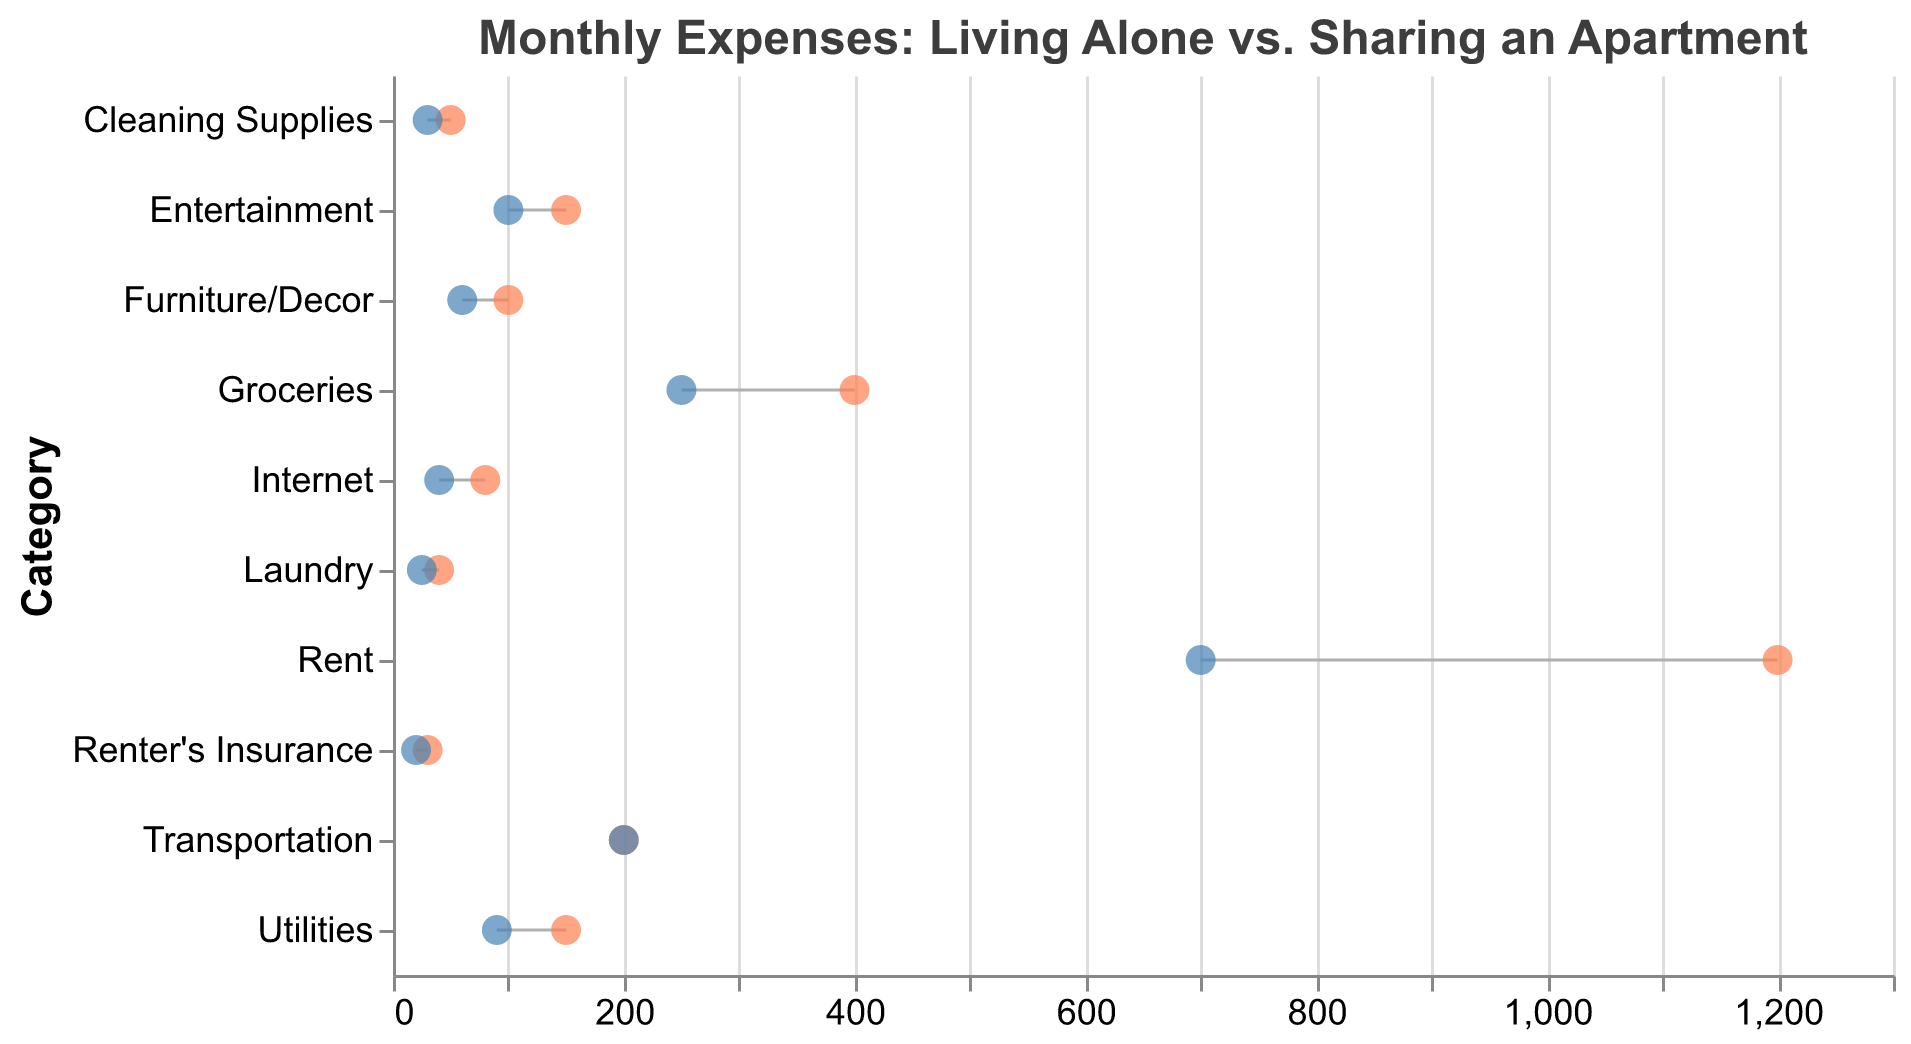Which category has the highest expense when living alone? Look at the orange circles representing "Living Alone" across all categories, the highest value is 1200 in the "Rent" category.
Answer: Rent What color is used to represent expenses for sharing an apartment? The circles representing expenses for "Sharing Apartment" are blue.
Answer: Blue What is the difference in rent between living alone and sharing an apartment? Subtract the rent cost for "Sharing Apartment" from the rent cost for "Living Alone": 1200 - 700 = 500.
Answer: 500 How much do utilities cost when living alone compared to sharing an apartment? The cost for "Utilities" when living alone is 150, and when sharing an apartment, it is 90.
Answer: 150 for living alone, 90 for sharing an apartment Which category shows no cost difference between living alone and sharing an apartment? Look for categories where the orange and blue circles are aligned; this happens for "Transportation" where both costs are 200.
Answer: Transportation Calculate the total monthly expense for living alone across all categories. Sum the "Living Alone" values: (1200 + 150 + 400 + 80 + 50 + 100 + 30 + 200 + 150 + 40) = 2400.
Answer: 2400 What is the average expense for groceries in both scenarios? For "Groceries," living alone is 400 and sharing an apartment is 250. Average is (400 + 250) / 2 = 325.
Answer: 325 Compare the cost difference for entertainment between living alone and sharing an apartment. Subtract the entertainment expense for sharing an apartment from living alone: 150 - 100 = 50.
Answer: 50 In which category do you save the most when sharing an apartment? Compare the savings across all categories: "Rent" has the highest difference of 500.
Answer: Rent 